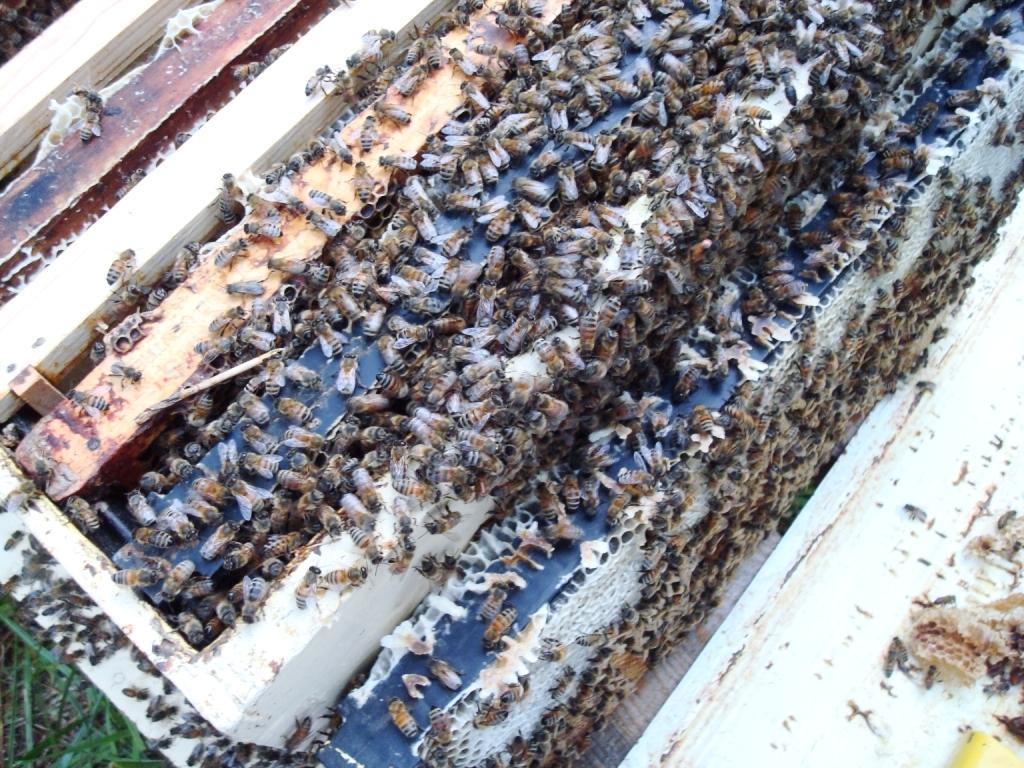Describe this image in one or two sentences. In this image we can see a honey bee hive box. There are many honey bees in the image. 